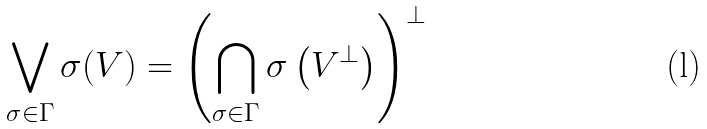Convert formula to latex. <formula><loc_0><loc_0><loc_500><loc_500>\bigvee _ { \sigma \in \Gamma } \sigma ( V ) = \left ( \bigcap _ { \sigma \in \Gamma } \sigma \left ( V ^ { \perp } \right ) \right ) ^ { \perp }</formula> 